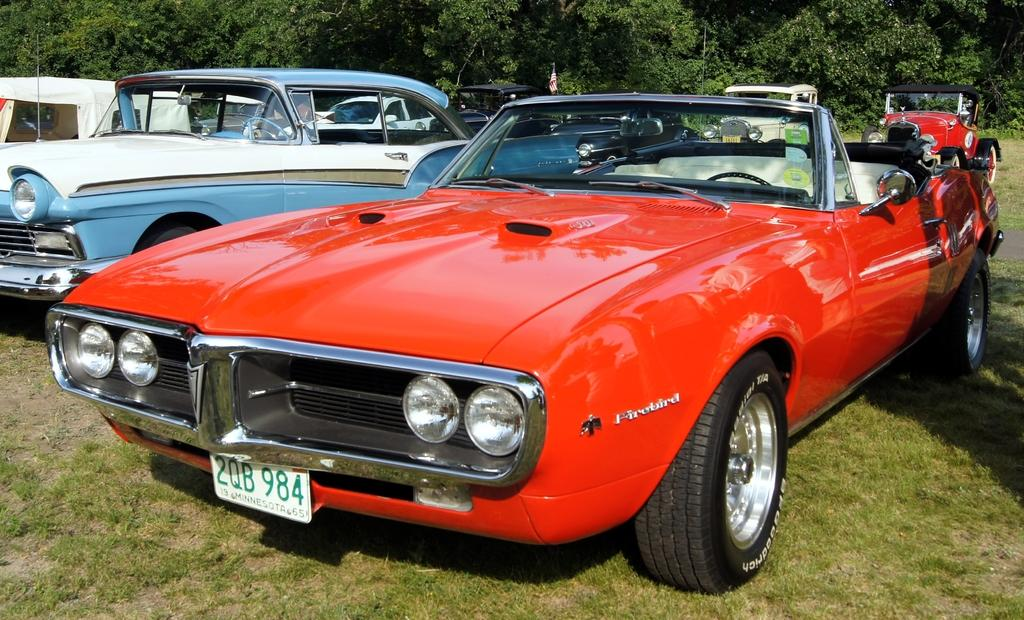What is the main subject of the image? The main subject of the image is many vehicles. Where are the vehicles located? The vehicles are on the grass. What can be seen in the background of the image? There are many trees in the background of the image. How many feathers can be seen on the vehicles in the image? There are no feathers present on the vehicles in the image. What type of mice can be seen running around the vehicles in the image? There are no mice present in the image. 